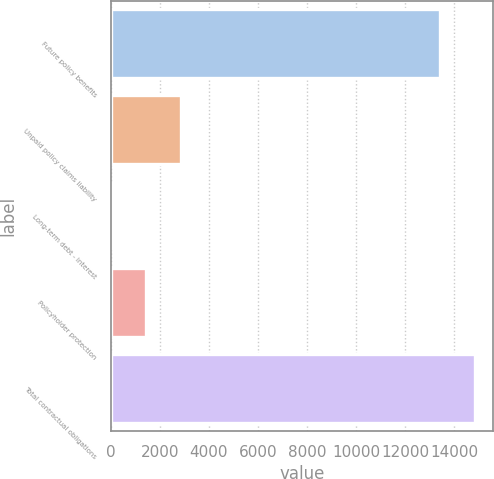Convert chart to OTSL. <chart><loc_0><loc_0><loc_500><loc_500><bar_chart><fcel>Future policy benefits<fcel>Unpaid policy claims liability<fcel>Long-term debt - interest<fcel>Policyholder protection<fcel>Total contractual obligations<nl><fcel>13412<fcel>2881.8<fcel>14<fcel>1447.9<fcel>14845.9<nl></chart> 